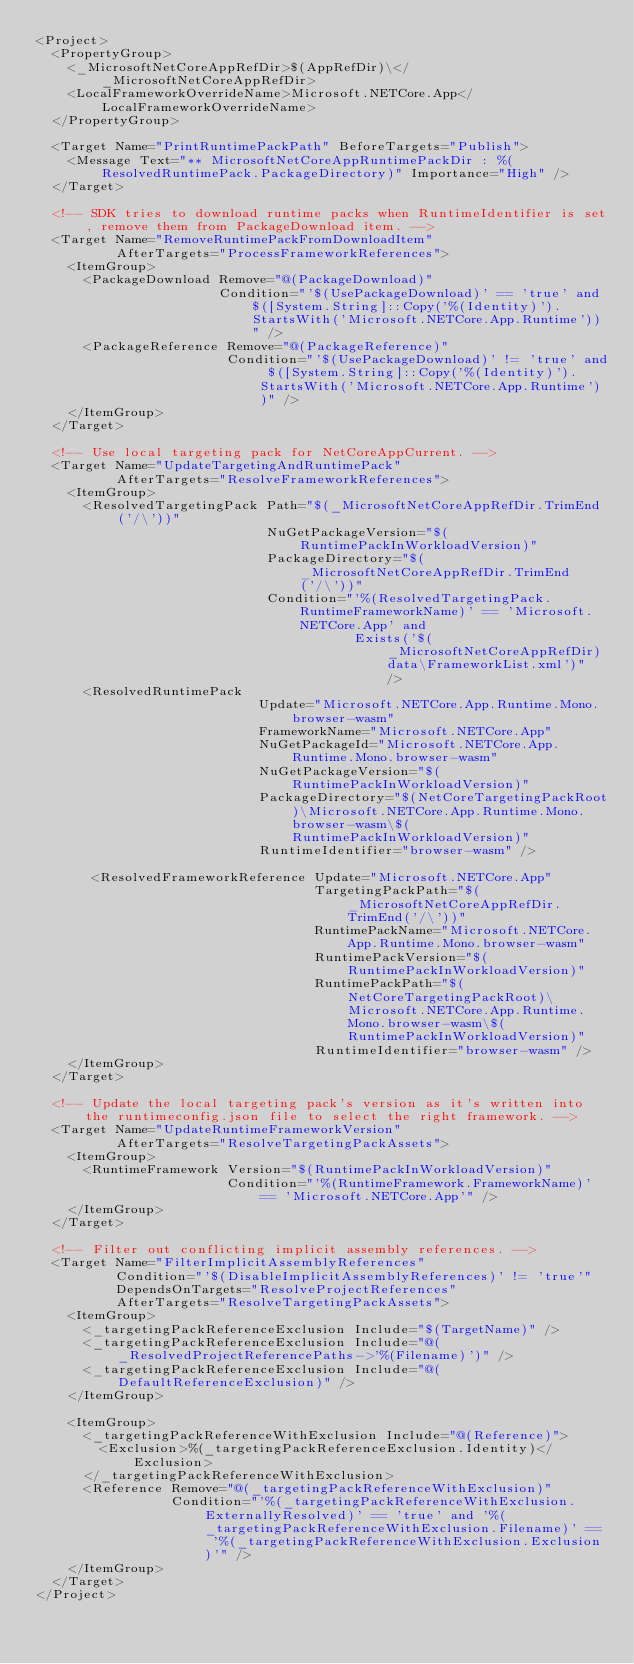Convert code to text. <code><loc_0><loc_0><loc_500><loc_500><_XML_><Project>
  <PropertyGroup>
    <_MicrosoftNetCoreAppRefDir>$(AppRefDir)\</_MicrosoftNetCoreAppRefDir>
    <LocalFrameworkOverrideName>Microsoft.NETCore.App</LocalFrameworkOverrideName>
  </PropertyGroup>

  <Target Name="PrintRuntimePackPath" BeforeTargets="Publish">
    <Message Text="** MicrosoftNetCoreAppRuntimePackDir : %(ResolvedRuntimePack.PackageDirectory)" Importance="High" />
  </Target>

  <!-- SDK tries to download runtime packs when RuntimeIdentifier is set, remove them from PackageDownload item. -->
  <Target Name="RemoveRuntimePackFromDownloadItem"
          AfterTargets="ProcessFrameworkReferences">
    <ItemGroup>
      <PackageDownload Remove="@(PackageDownload)"
                       Condition="'$(UsePackageDownload)' == 'true' and $([System.String]::Copy('%(Identity)').StartsWith('Microsoft.NETCore.App.Runtime'))" />
      <PackageReference Remove="@(PackageReference)"
                        Condition="'$(UsePackageDownload)' != 'true' and $([System.String]::Copy('%(Identity)').StartsWith('Microsoft.NETCore.App.Runtime'))" />
    </ItemGroup>
  </Target>

  <!-- Use local targeting pack for NetCoreAppCurrent. -->
  <Target Name="UpdateTargetingAndRuntimePack"
          AfterTargets="ResolveFrameworkReferences">
    <ItemGroup>
      <ResolvedTargetingPack Path="$(_MicrosoftNetCoreAppRefDir.TrimEnd('/\'))"
                             NuGetPackageVersion="$(RuntimePackInWorkloadVersion)"
                             PackageDirectory="$(_MicrosoftNetCoreAppRefDir.TrimEnd('/\'))"
                             Condition="'%(ResolvedTargetingPack.RuntimeFrameworkName)' == 'Microsoft.NETCore.App' and
                                        Exists('$(_MicrosoftNetCoreAppRefDir)data\FrameworkList.xml')" />
      <ResolvedRuntimePack
                            Update="Microsoft.NETCore.App.Runtime.Mono.browser-wasm"
                            FrameworkName="Microsoft.NETCore.App"
                            NuGetPackageId="Microsoft.NETCore.App.Runtime.Mono.browser-wasm"
                            NuGetPackageVersion="$(RuntimePackInWorkloadVersion)"
                            PackageDirectory="$(NetCoreTargetingPackRoot)\Microsoft.NETCore.App.Runtime.Mono.browser-wasm\$(RuntimePackInWorkloadVersion)"
                            RuntimeIdentifier="browser-wasm" />

       <ResolvedFrameworkReference Update="Microsoft.NETCore.App"
                                   TargetingPackPath="$(_MicrosoftNetCoreAppRefDir.TrimEnd('/\'))"
                                   RuntimePackName="Microsoft.NETCore.App.Runtime.Mono.browser-wasm"
                                   RuntimePackVersion="$(RuntimePackInWorkloadVersion)"
                                   RuntimePackPath="$(NetCoreTargetingPackRoot)\Microsoft.NETCore.App.Runtime.Mono.browser-wasm\$(RuntimePackInWorkloadVersion)"
                                   RuntimeIdentifier="browser-wasm" />
    </ItemGroup>
  </Target>

  <!-- Update the local targeting pack's version as it's written into the runtimeconfig.json file to select the right framework. -->
  <Target Name="UpdateRuntimeFrameworkVersion"
          AfterTargets="ResolveTargetingPackAssets">
    <ItemGroup>
      <RuntimeFramework Version="$(RuntimePackInWorkloadVersion)"
                        Condition="'%(RuntimeFramework.FrameworkName)' == 'Microsoft.NETCore.App'" />
    </ItemGroup>
  </Target>

  <!-- Filter out conflicting implicit assembly references. -->
  <Target Name="FilterImplicitAssemblyReferences"
          Condition="'$(DisableImplicitAssemblyReferences)' != 'true'"
          DependsOnTargets="ResolveProjectReferences"
          AfterTargets="ResolveTargetingPackAssets">
    <ItemGroup>
      <_targetingPackReferenceExclusion Include="$(TargetName)" />
      <_targetingPackReferenceExclusion Include="@(_ResolvedProjectReferencePaths->'%(Filename)')" />
      <_targetingPackReferenceExclusion Include="@(DefaultReferenceExclusion)" />
    </ItemGroup>

    <ItemGroup>
      <_targetingPackReferenceWithExclusion Include="@(Reference)">
        <Exclusion>%(_targetingPackReferenceExclusion.Identity)</Exclusion>
      </_targetingPackReferenceWithExclusion>
      <Reference Remove="@(_targetingPackReferenceWithExclusion)"
                 Condition="'%(_targetingPackReferenceWithExclusion.ExternallyResolved)' == 'true' and '%(_targetingPackReferenceWithExclusion.Filename)' == '%(_targetingPackReferenceWithExclusion.Exclusion)'" />
    </ItemGroup>
  </Target>
</Project>
</code> 